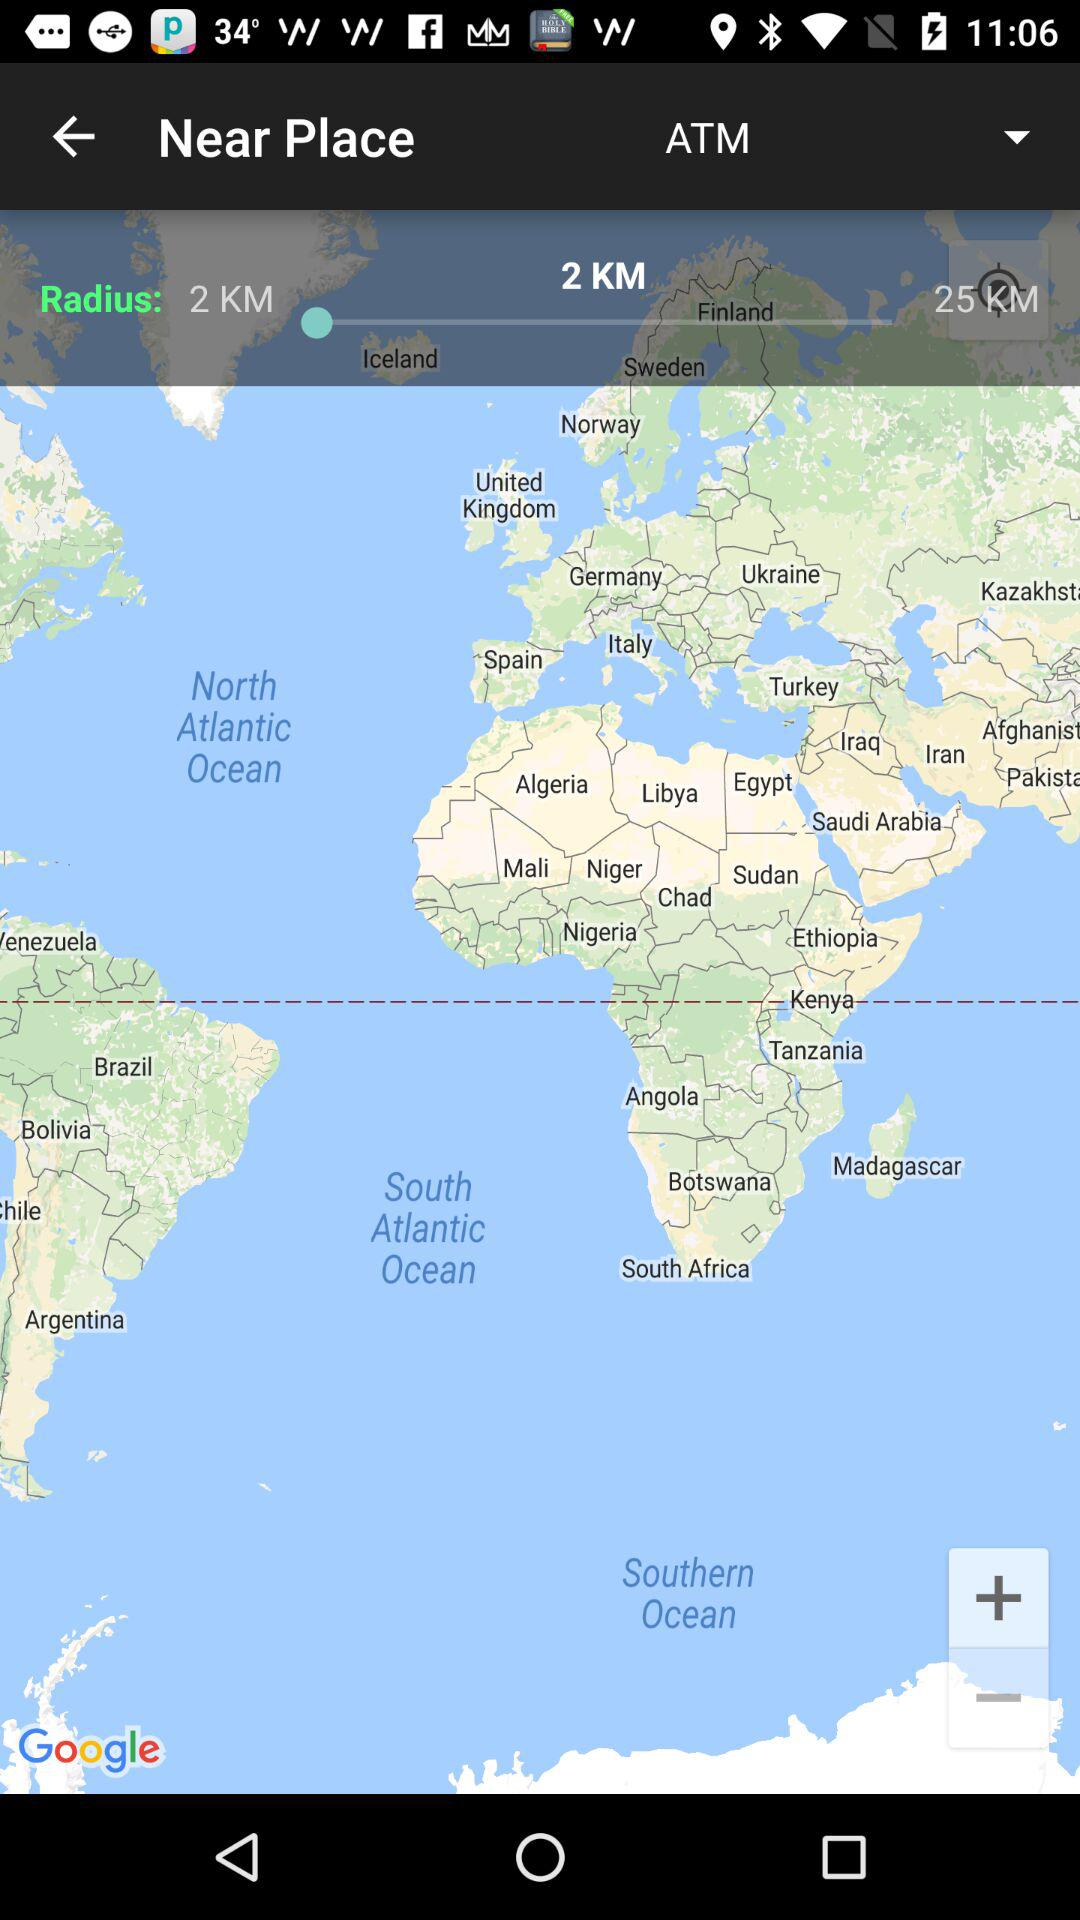How many more km are there in the 25km radius than the 2km radius?
Answer the question using a single word or phrase. 23 